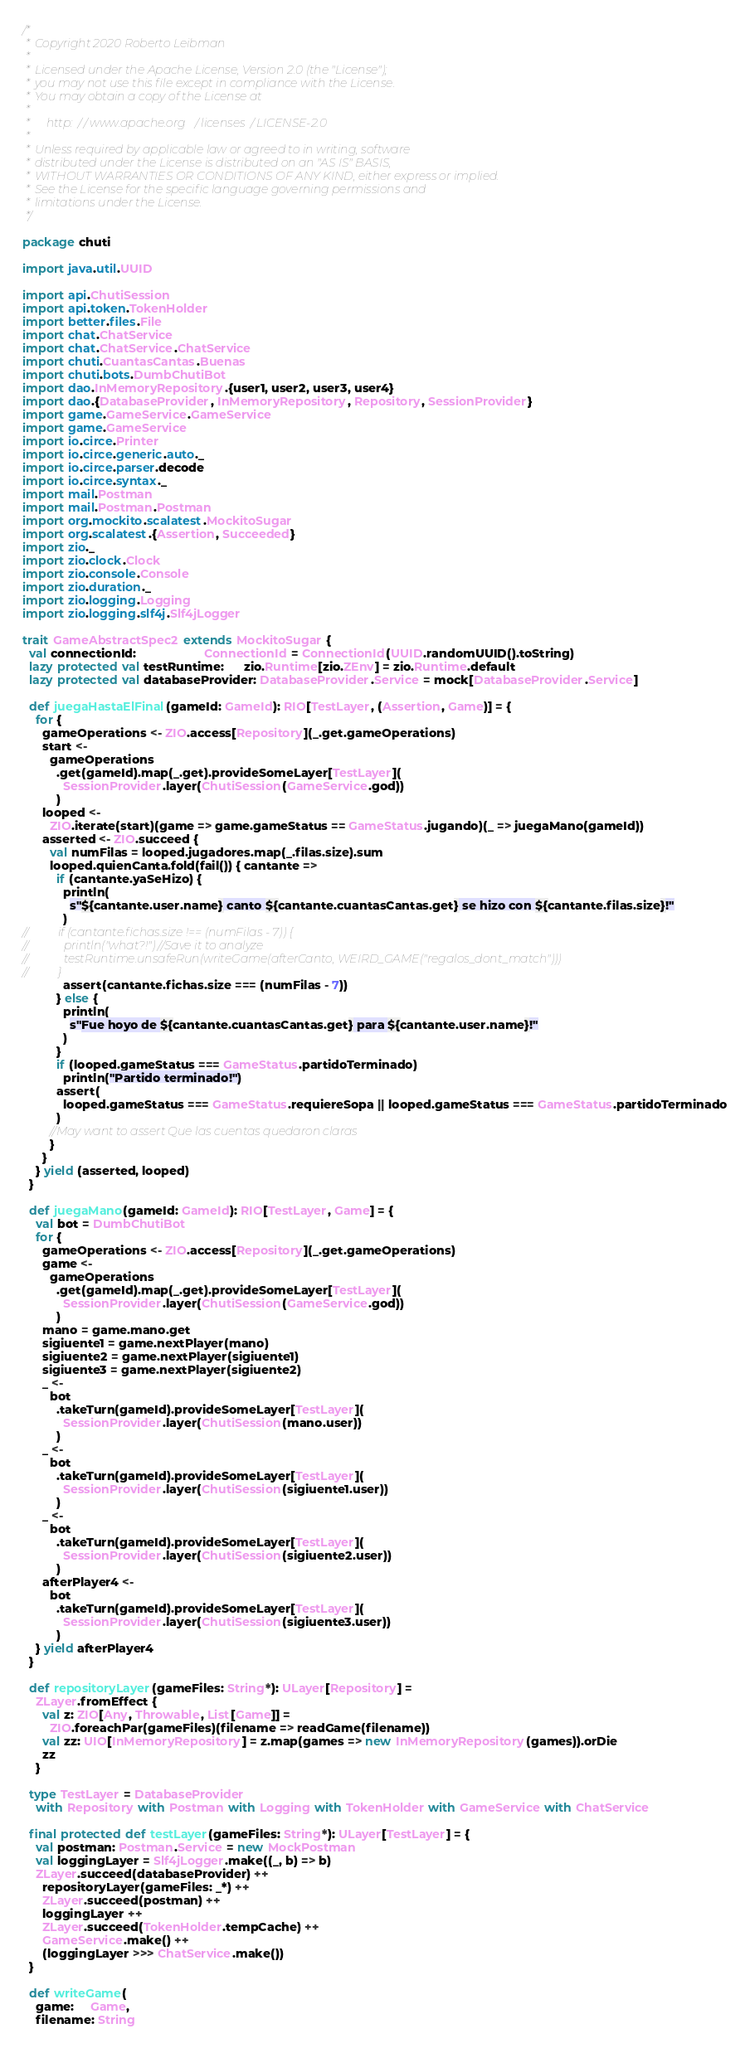Convert code to text. <code><loc_0><loc_0><loc_500><loc_500><_Scala_>/*
 * Copyright 2020 Roberto Leibman
 *
 * Licensed under the Apache License, Version 2.0 (the "License");
 * you may not use this file except in compliance with the License.
 * You may obtain a copy of the License at
 *
 *     http://www.apache.org/licenses/LICENSE-2.0
 *
 * Unless required by applicable law or agreed to in writing, software
 * distributed under the License is distributed on an "AS IS" BASIS,
 * WITHOUT WARRANTIES OR CONDITIONS OF ANY KIND, either express or implied.
 * See the License for the specific language governing permissions and
 * limitations under the License.
 */

package chuti

import java.util.UUID

import api.ChutiSession
import api.token.TokenHolder
import better.files.File
import chat.ChatService
import chat.ChatService.ChatService
import chuti.CuantasCantas.Buenas
import chuti.bots.DumbChutiBot
import dao.InMemoryRepository.{user1, user2, user3, user4}
import dao.{DatabaseProvider, InMemoryRepository, Repository, SessionProvider}
import game.GameService.GameService
import game.GameService
import io.circe.Printer
import io.circe.generic.auto._
import io.circe.parser.decode
import io.circe.syntax._
import mail.Postman
import mail.Postman.Postman
import org.mockito.scalatest.MockitoSugar
import org.scalatest.{Assertion, Succeeded}
import zio._
import zio.clock.Clock
import zio.console.Console
import zio.duration._
import zio.logging.Logging
import zio.logging.slf4j.Slf4jLogger

trait GameAbstractSpec2 extends MockitoSugar {
  val connectionId:                    ConnectionId = ConnectionId(UUID.randomUUID().toString)
  lazy protected val testRuntime:      zio.Runtime[zio.ZEnv] = zio.Runtime.default
  lazy protected val databaseProvider: DatabaseProvider.Service = mock[DatabaseProvider.Service]

  def juegaHastaElFinal(gameId: GameId): RIO[TestLayer, (Assertion, Game)] = {
    for {
      gameOperations <- ZIO.access[Repository](_.get.gameOperations)
      start <-
        gameOperations
          .get(gameId).map(_.get).provideSomeLayer[TestLayer](
            SessionProvider.layer(ChutiSession(GameService.god))
          )
      looped <-
        ZIO.iterate(start)(game => game.gameStatus == GameStatus.jugando)(_ => juegaMano(gameId))
      asserted <- ZIO.succeed {
        val numFilas = looped.jugadores.map(_.filas.size).sum
        looped.quienCanta.fold(fail()) { cantante =>
          if (cantante.yaSeHizo) {
            println(
              s"${cantante.user.name} canto ${cantante.cuantasCantas.get} se hizo con ${cantante.filas.size}!"
            )
//          if (cantante.fichas.size !== (numFilas - 7)) {
//            println("what?!") //Save it to analyze
//            testRuntime.unsafeRun(writeGame(afterCanto, WEIRD_GAME("regalos_dont_match")))
//          }
            assert(cantante.fichas.size === (numFilas - 7))
          } else {
            println(
              s"Fue hoyo de ${cantante.cuantasCantas.get} para ${cantante.user.name}!"
            )
          }
          if (looped.gameStatus === GameStatus.partidoTerminado)
            println("Partido terminado!")
          assert(
            looped.gameStatus === GameStatus.requiereSopa || looped.gameStatus === GameStatus.partidoTerminado
          )
        //May want to assert Que las cuentas quedaron claras
        }
      }
    } yield (asserted, looped)
  }

  def juegaMano(gameId: GameId): RIO[TestLayer, Game] = {
    val bot = DumbChutiBot
    for {
      gameOperations <- ZIO.access[Repository](_.get.gameOperations)
      game <-
        gameOperations
          .get(gameId).map(_.get).provideSomeLayer[TestLayer](
            SessionProvider.layer(ChutiSession(GameService.god))
          )
      mano = game.mano.get
      sigiuente1 = game.nextPlayer(mano)
      sigiuente2 = game.nextPlayer(sigiuente1)
      sigiuente3 = game.nextPlayer(sigiuente2)
      _ <-
        bot
          .takeTurn(gameId).provideSomeLayer[TestLayer](
            SessionProvider.layer(ChutiSession(mano.user))
          )
      _ <-
        bot
          .takeTurn(gameId).provideSomeLayer[TestLayer](
            SessionProvider.layer(ChutiSession(sigiuente1.user))
          )
      _ <-
        bot
          .takeTurn(gameId).provideSomeLayer[TestLayer](
            SessionProvider.layer(ChutiSession(sigiuente2.user))
          )
      afterPlayer4 <-
        bot
          .takeTurn(gameId).provideSomeLayer[TestLayer](
            SessionProvider.layer(ChutiSession(sigiuente3.user))
          )
    } yield afterPlayer4
  }

  def repositoryLayer(gameFiles: String*): ULayer[Repository] =
    ZLayer.fromEffect {
      val z: ZIO[Any, Throwable, List[Game]] =
        ZIO.foreachPar(gameFiles)(filename => readGame(filename))
      val zz: UIO[InMemoryRepository] = z.map(games => new InMemoryRepository(games)).orDie
      zz
    }

  type TestLayer = DatabaseProvider
    with Repository with Postman with Logging with TokenHolder with GameService with ChatService

  final protected def testLayer(gameFiles: String*): ULayer[TestLayer] = {
    val postman: Postman.Service = new MockPostman
    val loggingLayer = Slf4jLogger.make((_, b) => b)
    ZLayer.succeed(databaseProvider) ++
      repositoryLayer(gameFiles: _*) ++
      ZLayer.succeed(postman) ++
      loggingLayer ++
      ZLayer.succeed(TokenHolder.tempCache) ++
      GameService.make() ++
      (loggingLayer >>> ChatService.make())
  }

  def writeGame(
    game:     Game,
    filename: String</code> 